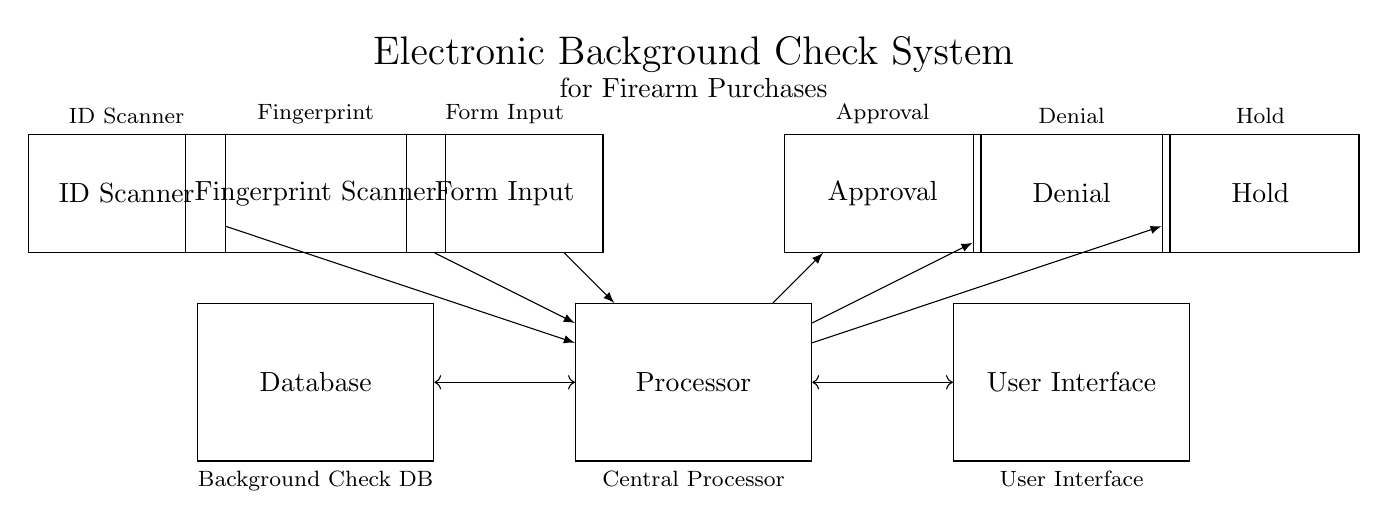What are the components of the circuit? The circuit consists of an ID Scanner, a Fingerprint Scanner, a Form Input, a Processor, a Database, a User Interface, and output options of Approval, Denial, and Hold. Each component serves a specific role in the electronic background check system for firearm purchases.
Answer: ID Scanner, Fingerprint Scanner, Form Input, Processor, Database, User Interface, Approval, Denial, Hold What is the role of the Processor? The Processor acts as the central unit that processes the inputs from the ID Scanner, Fingerprint Scanner, and Form Input, while also interacting with the Database. Its primary function is to evaluate the data and generate either an Approval, Denial, or Hold response.
Answer: Central processing unit What type of inputs does the Processor receive? The Processor receives inputs from an ID Scanner, a Fingerprint Scanner, and Form Input. These inputs are necessary for conducting the background check on the firearm purchaser, ensuring that all data is considered before a decision is made.
Answer: ID Scanner, Fingerprint Scanner, Form Input What outputs does the Processor provide? The Processor provides three types of outputs: Approval, Denial, and Hold. These outputs indicate the possible decisions after processing the input data regarding the firearm purchase.
Answer: Approval, Denial, Hold What is the connection type between the Database and Processor? The Database and Processor are connected with a bidirectional connection. This allows the Processor to send requests to the Database and receive information back as necessary to evaluate the background check.
Answer: Bidirectional What is the purpose of the User Interface in this system? The User Interface is designed to facilitate user interaction with the electronic background check system. It outputs the decision made by the Processor and likely allows users to input data such as forms or scans.
Answer: Facilitate user interaction 